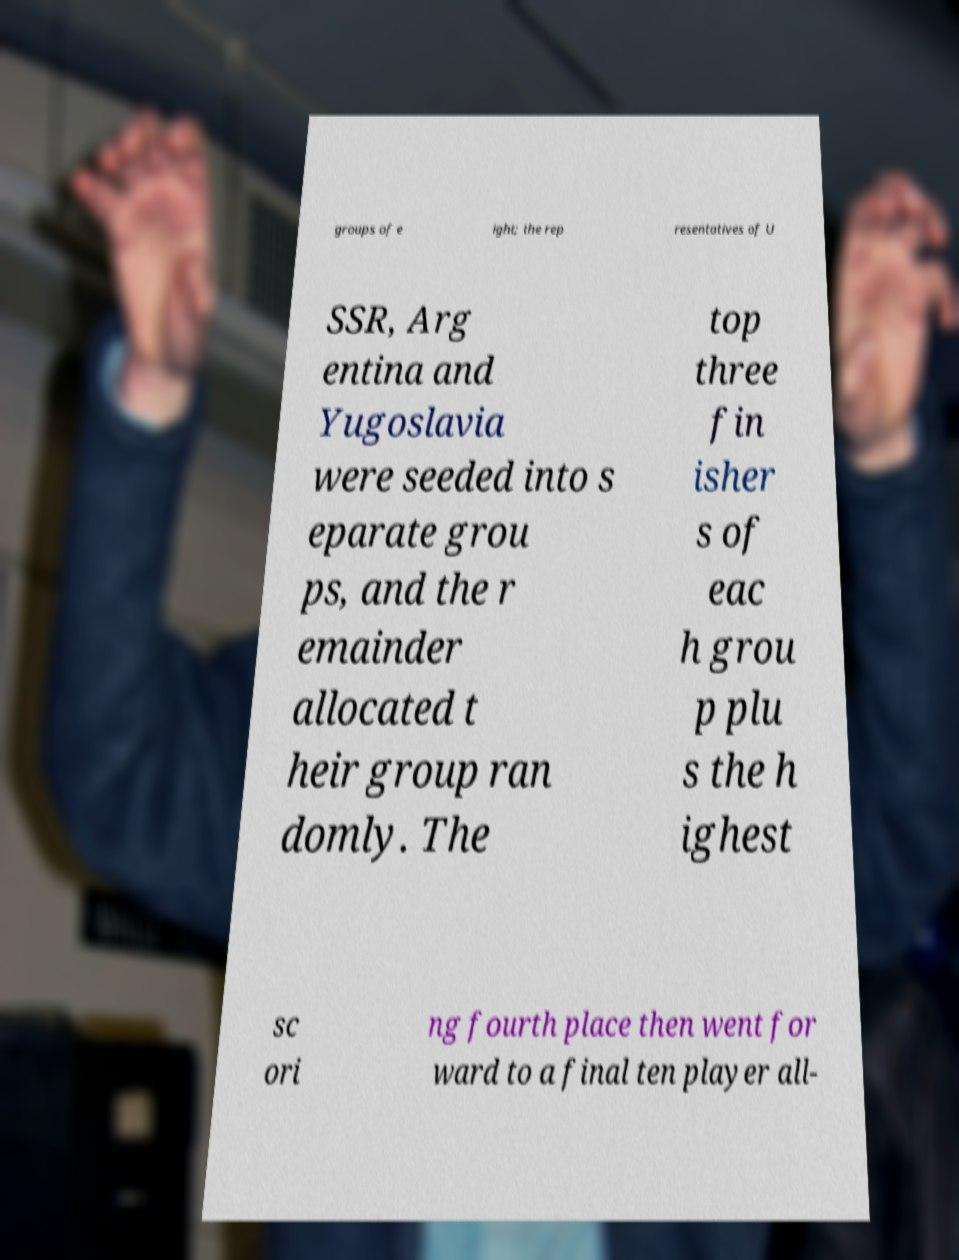Could you assist in decoding the text presented in this image and type it out clearly? groups of e ight; the rep resentatives of U SSR, Arg entina and Yugoslavia were seeded into s eparate grou ps, and the r emainder allocated t heir group ran domly. The top three fin isher s of eac h grou p plu s the h ighest sc ori ng fourth place then went for ward to a final ten player all- 